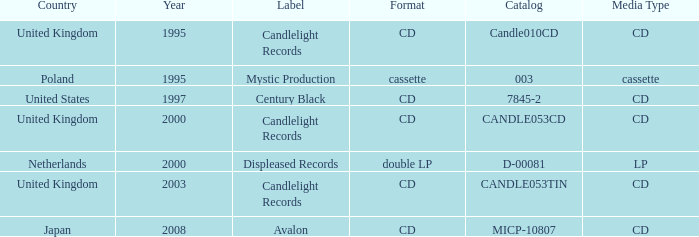What year did Japan form a label? 2008.0. 